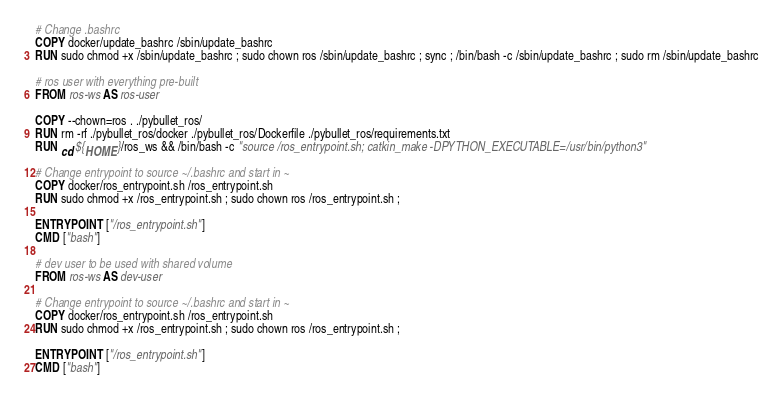Convert code to text. <code><loc_0><loc_0><loc_500><loc_500><_Dockerfile_># Change .bashrc
COPY docker/update_bashrc /sbin/update_bashrc
RUN sudo chmod +x /sbin/update_bashrc ; sudo chown ros /sbin/update_bashrc ; sync ; /bin/bash -c /sbin/update_bashrc ; sudo rm /sbin/update_bashrc

# ros user with everything pre-built
FROM ros-ws AS ros-user

COPY --chown=ros . ./pybullet_ros/
RUN rm -rf ./pybullet_ros/docker ./pybullet_ros/Dockerfile ./pybullet_ros/requirements.txt
RUN cd ${HOME}/ros_ws && /bin/bash -c "source /ros_entrypoint.sh; catkin_make -DPYTHON_EXECUTABLE=/usr/bin/python3"

# Change entrypoint to source ~/.bashrc and start in ~
COPY docker/ros_entrypoint.sh /ros_entrypoint.sh
RUN sudo chmod +x /ros_entrypoint.sh ; sudo chown ros /ros_entrypoint.sh ;

ENTRYPOINT ["/ros_entrypoint.sh"]
CMD ["bash"]

# dev user to be used with shared volume
FROM ros-ws AS dev-user

# Change entrypoint to source ~/.bashrc and start in ~
COPY docker/ros_entrypoint.sh /ros_entrypoint.sh
RUN sudo chmod +x /ros_entrypoint.sh ; sudo chown ros /ros_entrypoint.sh ;

ENTRYPOINT ["/ros_entrypoint.sh"]
CMD ["bash"]
</code> 